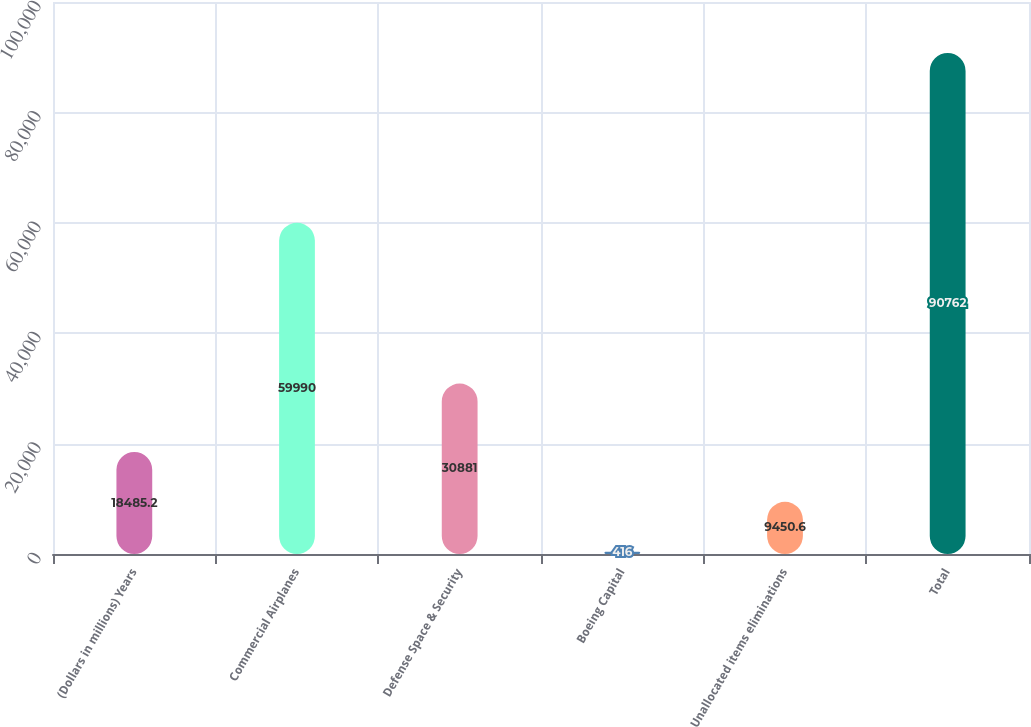Convert chart to OTSL. <chart><loc_0><loc_0><loc_500><loc_500><bar_chart><fcel>(Dollars in millions) Years<fcel>Commercial Airplanes<fcel>Defense Space & Security<fcel>Boeing Capital<fcel>Unallocated items eliminations<fcel>Total<nl><fcel>18485.2<fcel>59990<fcel>30881<fcel>416<fcel>9450.6<fcel>90762<nl></chart> 